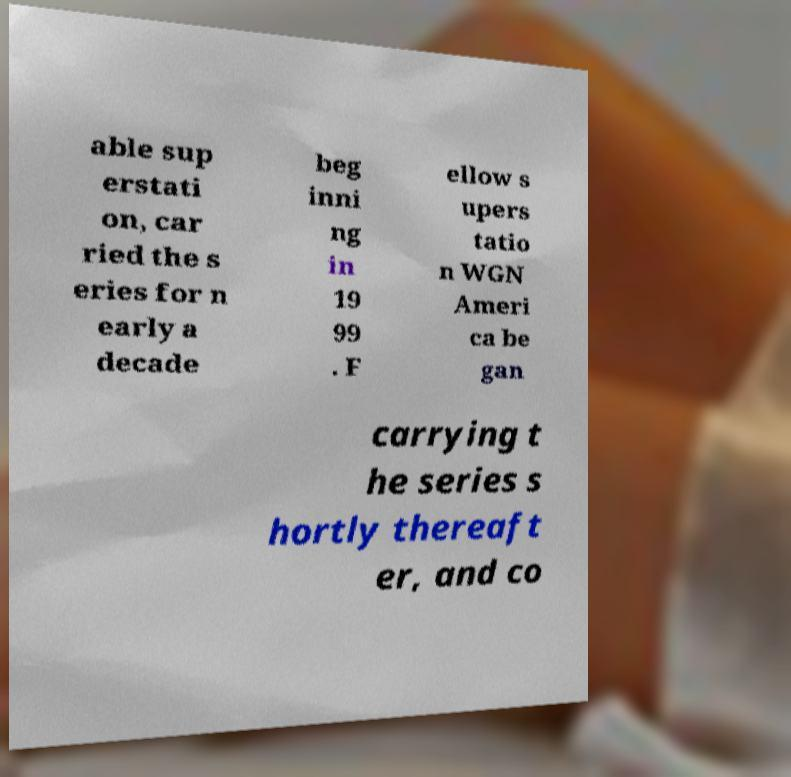Can you read and provide the text displayed in the image?This photo seems to have some interesting text. Can you extract and type it out for me? able sup erstati on, car ried the s eries for n early a decade beg inni ng in 19 99 . F ellow s upers tatio n WGN Ameri ca be gan carrying t he series s hortly thereaft er, and co 